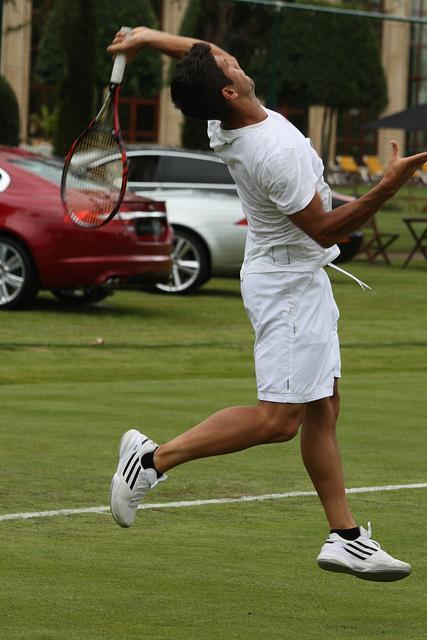How many cars are in the photo?
Give a very brief answer. 2. 